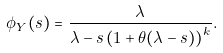<formula> <loc_0><loc_0><loc_500><loc_500>\phi _ { Y } ( s ) & = \frac { \lambda } { \lambda - s \left ( 1 + \theta ( \lambda - s ) \right ) ^ { k } } .</formula> 